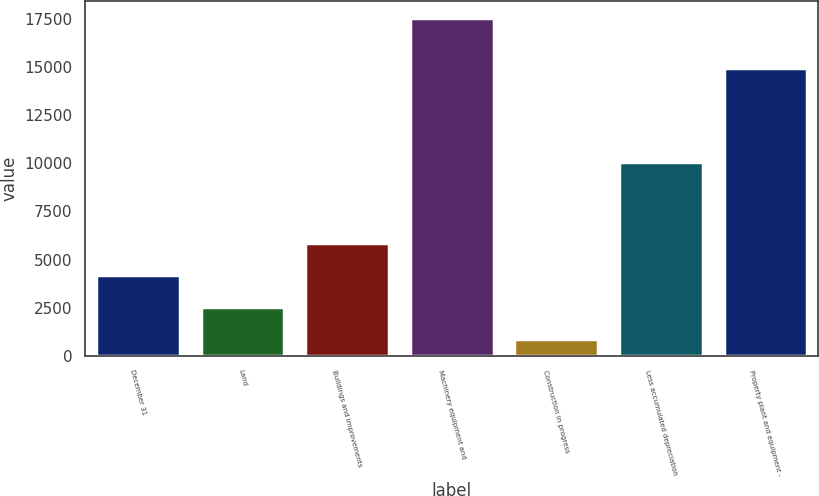Convert chart to OTSL. <chart><loc_0><loc_0><loc_500><loc_500><bar_chart><fcel>December 31<fcel>Land<fcel>Buildings and improvements<fcel>Machinery equipment and<fcel>Construction in progress<fcel>Less accumulated depreciation<fcel>Property plant and equipment -<nl><fcel>4202.2<fcel>2533.6<fcel>5870.8<fcel>17551<fcel>865<fcel>10065<fcel>14967<nl></chart> 